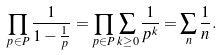<formula> <loc_0><loc_0><loc_500><loc_500>\prod _ { p \in P } { \frac { 1 } { 1 - { \frac { 1 } { p } } } } = \prod _ { p \in P } \sum _ { k \geq 0 } { \frac { 1 } { p ^ { k } } } = \sum _ { n } { \frac { 1 } { n } } .</formula> 